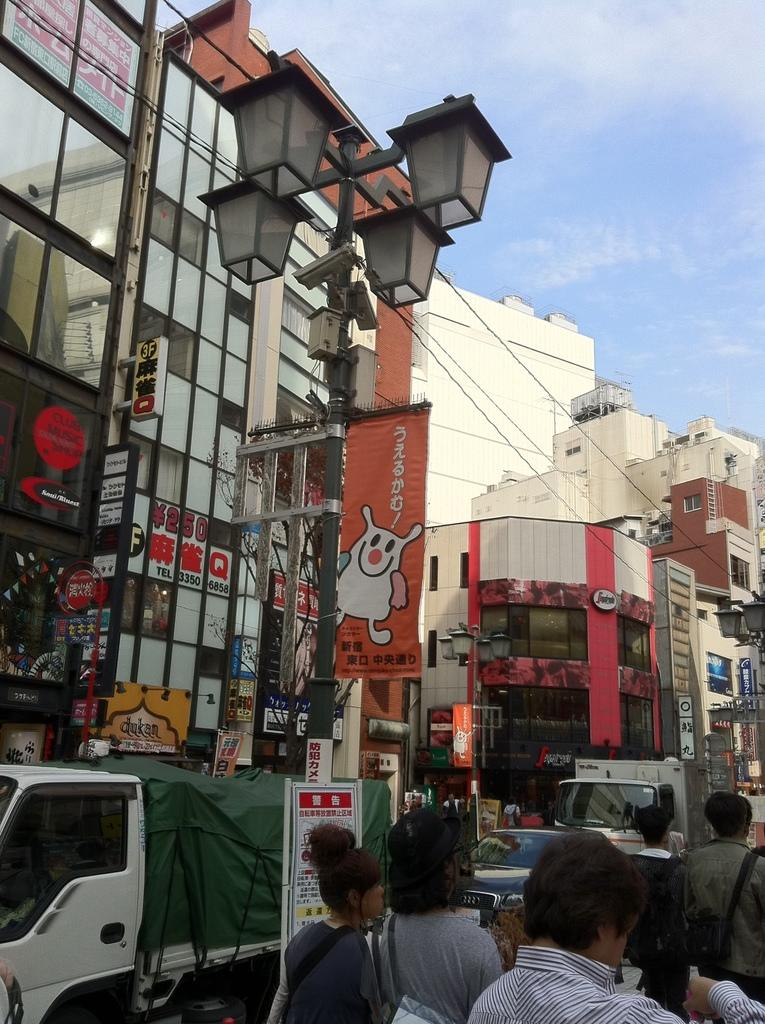What are the people in the image doing? The people in the image are walking on the road. What else is happening on the road? Vehicles are moving on the road. What can be seen in the background of the image? There are buildings, a banner, light poles, and wires present in the background. What is visible in the sky? The sky is visible with clouds. What type of cast can be seen on the lead actor in the image? There is no cast or lead actor present in the image; it features people walking on the road and vehicles moving on the road. What boundary is visible in the image? There is no boundary visible in the image; it features a road, buildings, and other elements in the background. 